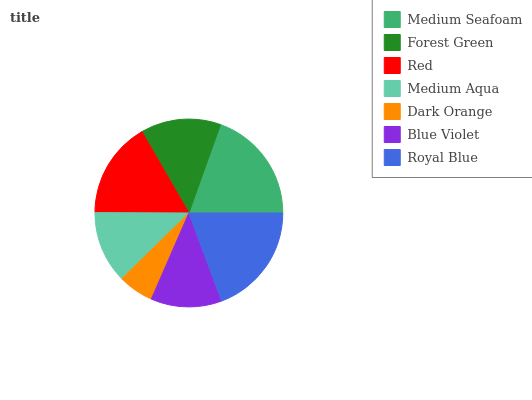Is Dark Orange the minimum?
Answer yes or no. Yes. Is Medium Seafoam the maximum?
Answer yes or no. Yes. Is Forest Green the minimum?
Answer yes or no. No. Is Forest Green the maximum?
Answer yes or no. No. Is Medium Seafoam greater than Forest Green?
Answer yes or no. Yes. Is Forest Green less than Medium Seafoam?
Answer yes or no. Yes. Is Forest Green greater than Medium Seafoam?
Answer yes or no. No. Is Medium Seafoam less than Forest Green?
Answer yes or no. No. Is Forest Green the high median?
Answer yes or no. Yes. Is Forest Green the low median?
Answer yes or no. Yes. Is Medium Seafoam the high median?
Answer yes or no. No. Is Dark Orange the low median?
Answer yes or no. No. 